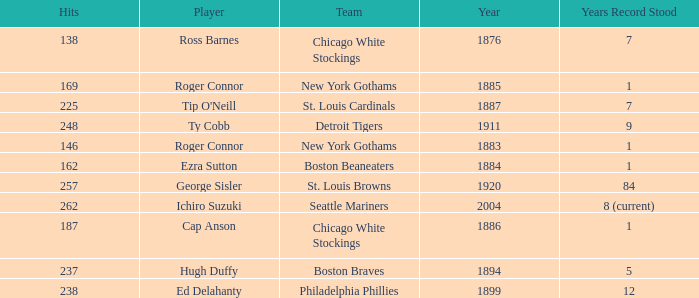Could you parse the entire table? {'header': ['Hits', 'Player', 'Team', 'Year', 'Years Record Stood'], 'rows': [['138', 'Ross Barnes', 'Chicago White Stockings', '1876', '7'], ['169', 'Roger Connor', 'New York Gothams', '1885', '1'], ['225', "Tip O'Neill", 'St. Louis Cardinals', '1887', '7'], ['248', 'Ty Cobb', 'Detroit Tigers', '1911', '9'], ['146', 'Roger Connor', 'New York Gothams', '1883', '1'], ['162', 'Ezra Sutton', 'Boston Beaneaters', '1884', '1'], ['257', 'George Sisler', 'St. Louis Browns', '1920', '84'], ['262', 'Ichiro Suzuki', 'Seattle Mariners', '2004', '8 (current)'], ['187', 'Cap Anson', 'Chicago White Stockings', '1886', '1'], ['237', 'Hugh Duffy', 'Boston Braves', '1894', '5'], ['238', 'Ed Delahanty', 'Philadelphia Phillies', '1899', '12']]} Name the hits for years before 1883 138.0. 